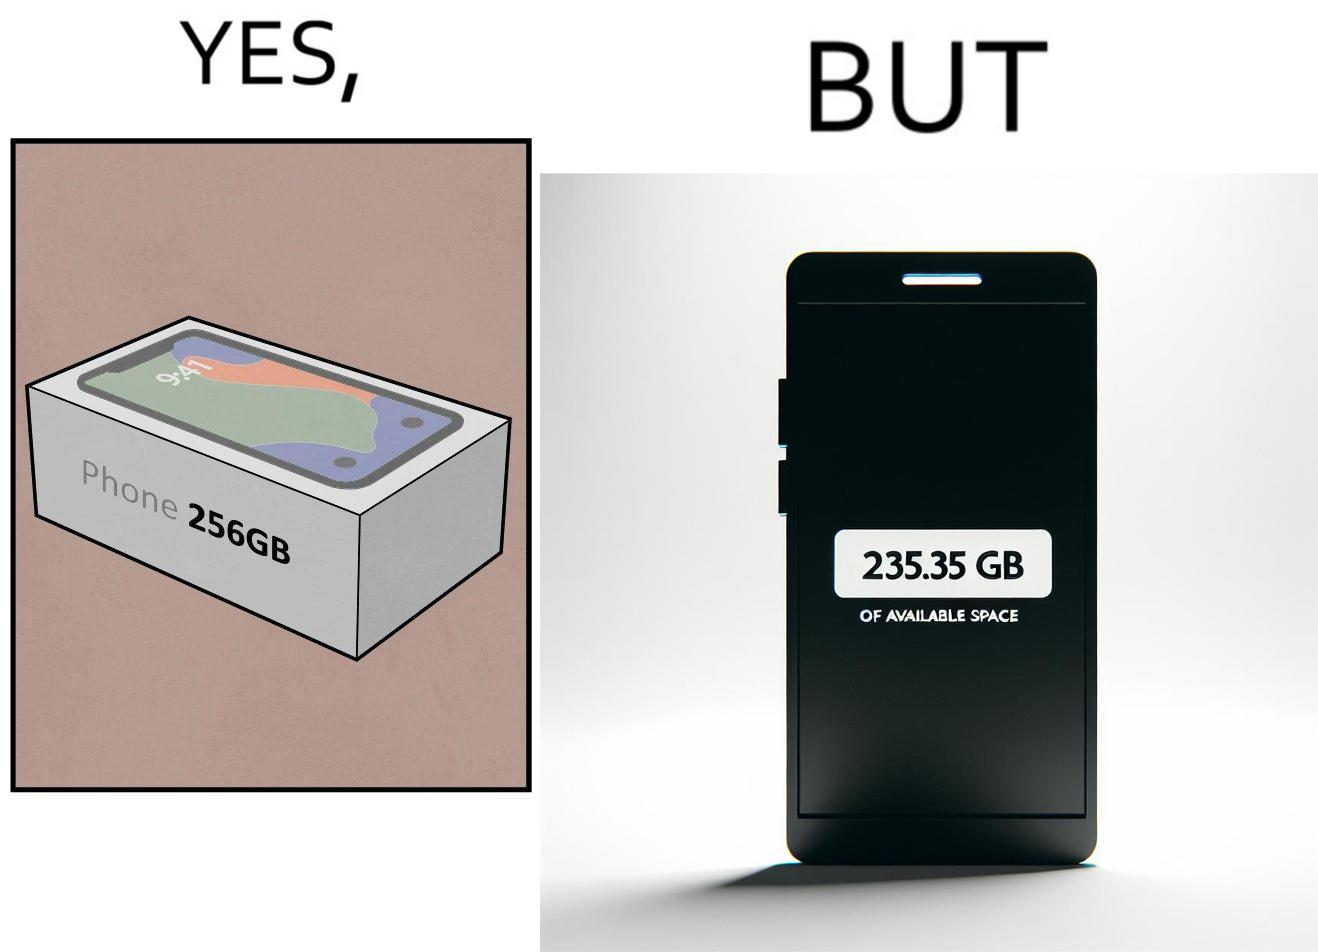Does this image contain satire or humor? Yes, this image is satirical. 